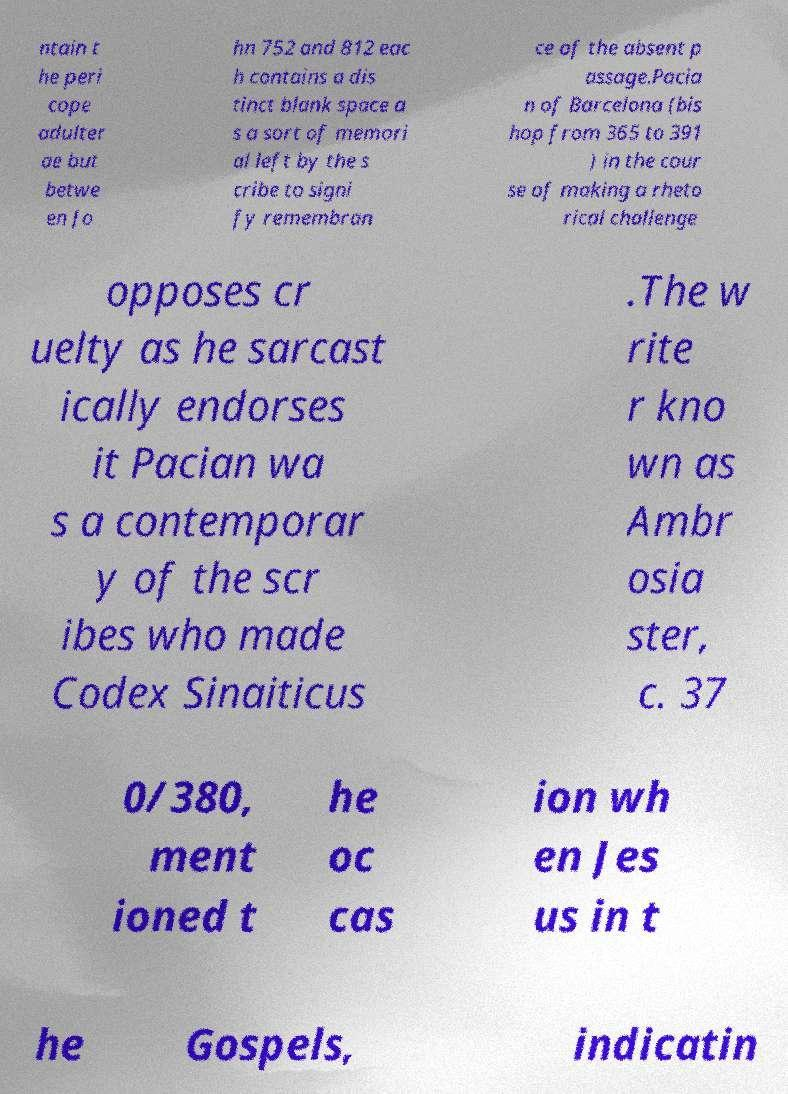Can you accurately transcribe the text from the provided image for me? ntain t he peri cope adulter ae but betwe en Jo hn 752 and 812 eac h contains a dis tinct blank space a s a sort of memori al left by the s cribe to signi fy remembran ce of the absent p assage.Pacia n of Barcelona (bis hop from 365 to 391 ) in the cour se of making a rheto rical challenge opposes cr uelty as he sarcast ically endorses it Pacian wa s a contemporar y of the scr ibes who made Codex Sinaiticus .The w rite r kno wn as Ambr osia ster, c. 37 0/380, ment ioned t he oc cas ion wh en Jes us in t he Gospels, indicatin 